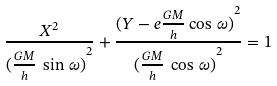Convert formula to latex. <formula><loc_0><loc_0><loc_500><loc_500>\frac { X ^ { 2 } } { { ( \frac { G M } { h } \, \sin \, \omega ) } ^ { 2 } } + \frac { { ( Y - e \frac { G M } { h } \cos \, \omega ) } ^ { 2 } } { { { ( \frac { G M } { h } \, \cos \, \omega ) } ^ { 2 } } } = 1</formula> 